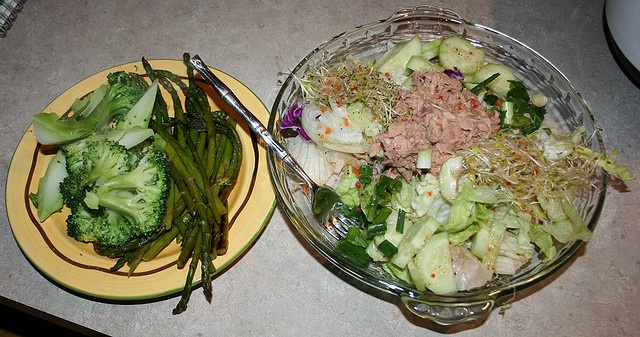Describe the objects in this image and their specific colors. I can see bowl in black, tan, darkgray, gray, and olive tones, broccoli in black, olive, and darkgreen tones, broccoli in black, darkgreen, olive, and darkgray tones, and fork in black, gray, white, and darkgray tones in this image. 